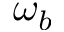<formula> <loc_0><loc_0><loc_500><loc_500>\omega _ { b }</formula> 